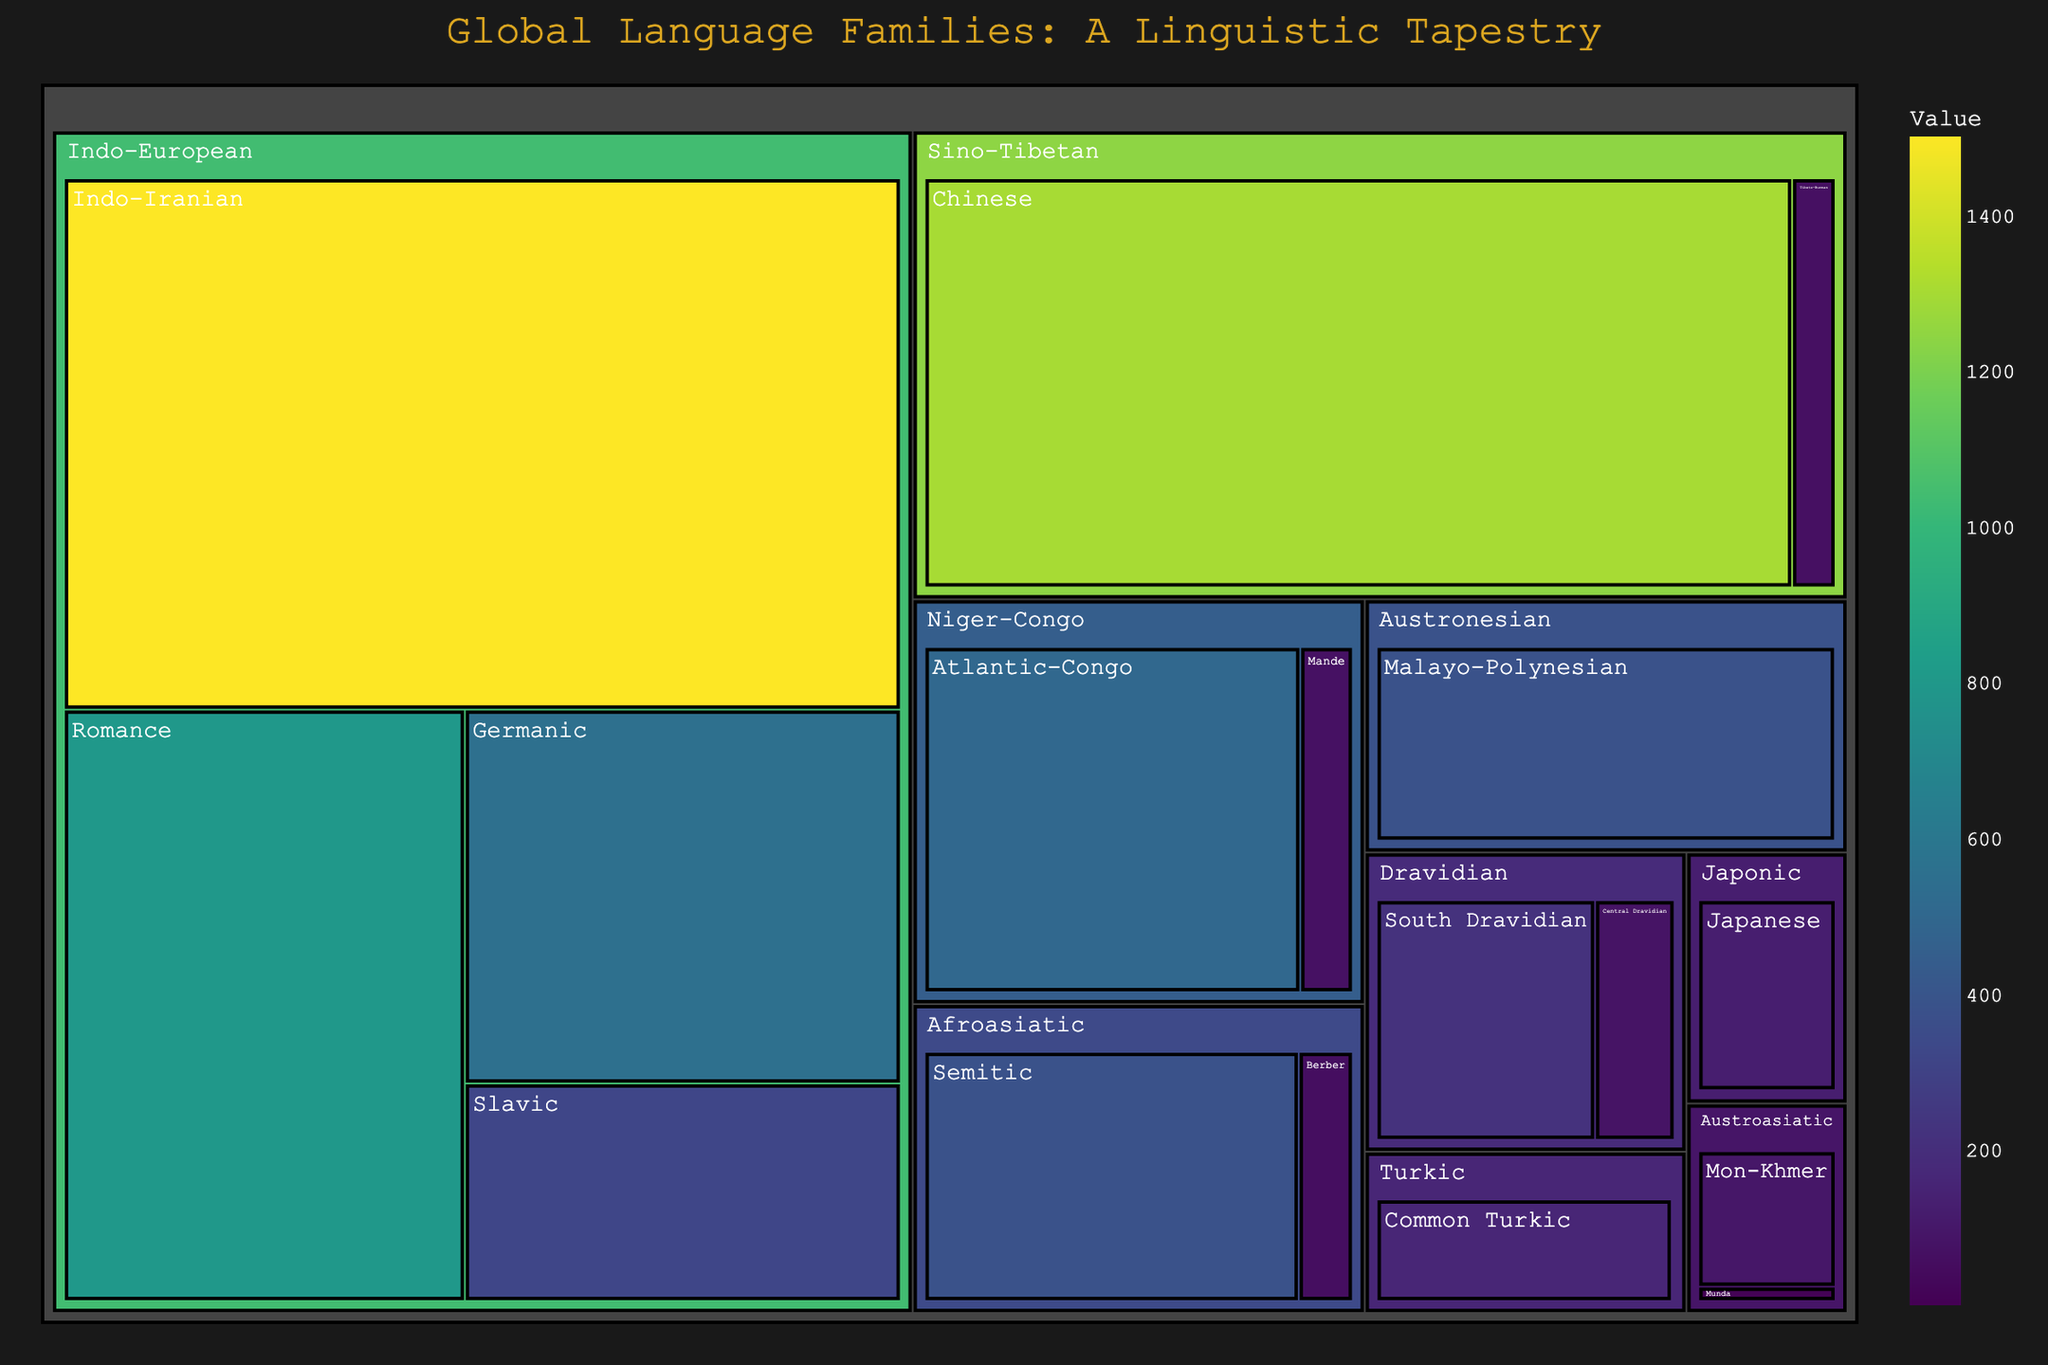What is the title of the figure? The title is displayed prominently at the top of the figure in a large, bold font. It reads "Global Language Families: A Linguistic Tapestry."
Answer: Global Language Families: A Linguistic Tapestry How many language families are represented in the figure? The treemap is divided into sections, each representing a different language family. Counting these sections, there are 8 language families: Indo-European, Sino-Tibetan, Afroasiatic, Niger-Congo, Austronesian, Dravidian, Japonic, and Turkic.
Answer: 8 Which language family has the highest number of speakers? By examining the relative sizes of the sections in the treemap, the Sino-Tibetan family, especially the Chinese branch, occupies the largest area, indicating it has the highest number of speakers.
Answer: Sino-Tibetan What is the combined number of speakers for the Indo-Iranian and Romance branches of the Indo-European family? The Indo-Iranian branch has 1500 million speakers, and the Romance branch has 800 million speakers. Summing these gives 1500 + 800 = 2300 million speakers.
Answer: 2300 million Which branch within the Sino-Tibetan family has more speakers, Chinese or Tibeto-Burman? The areas representing the Chinese and Tibeto-Burman branches can be compared. The Chinese branch has a larger area, indicating it has more speakers.
Answer: Chinese How many branches does the Austronesian family have? The sections within the Austronesian area of the treemap show two branches: Malayo-Polynesian and Formosan.
Answer: 2 What is the range of speakers within the Turkic family? The Turkic family includes the Common Turkic branch with 160 million speakers and the Oghur branch with 1.5 million speakers. The range is calculated as 160 - 1.5 = 158.5 million speakers.
Answer: 158.5 million Which family has a larger number of speakers, Niger-Congo or Austroasiatic? Comparing the sizes of the sections representing Niger-Congo and Austroasiatic, the Niger-Congo section is larger, indicating it has more speakers. Niger-Congo has 500 + 70 = 570 million speakers, while Austroasiatic has 95 + 10 = 105 million speakers.
Answer: Niger-Congo Which branch within the Afroasiatic family has more speakers? By comparing the areas of the Semitic and Berber branches in the Afroasiatic family, the Semitic branch is larger, indicating it has more speakers.
Answer: Semitic 